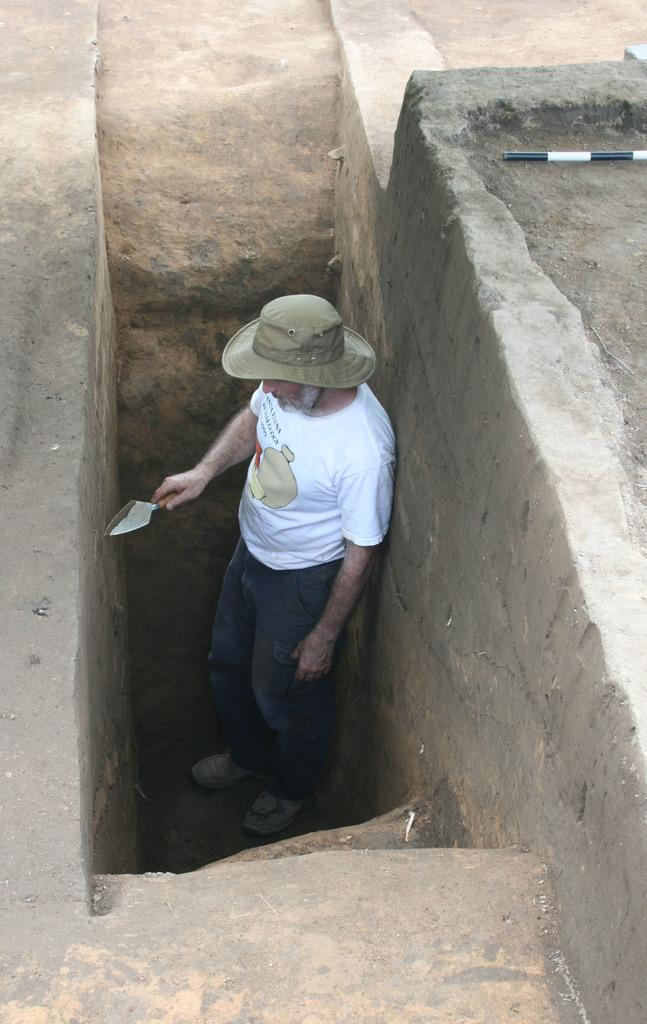Who is present in the image? There is a man in the image. What is the man doing in the image? The man is standing in a path. What is the man wearing in the image? The man is wearing a white T-shirt and a hat. What can be seen under the man's feet in the image? There is a floor in the image, and it is in cream color. What is the man's sister doing in the image? There is no mention of a sister in the image or the provided facts. --- 